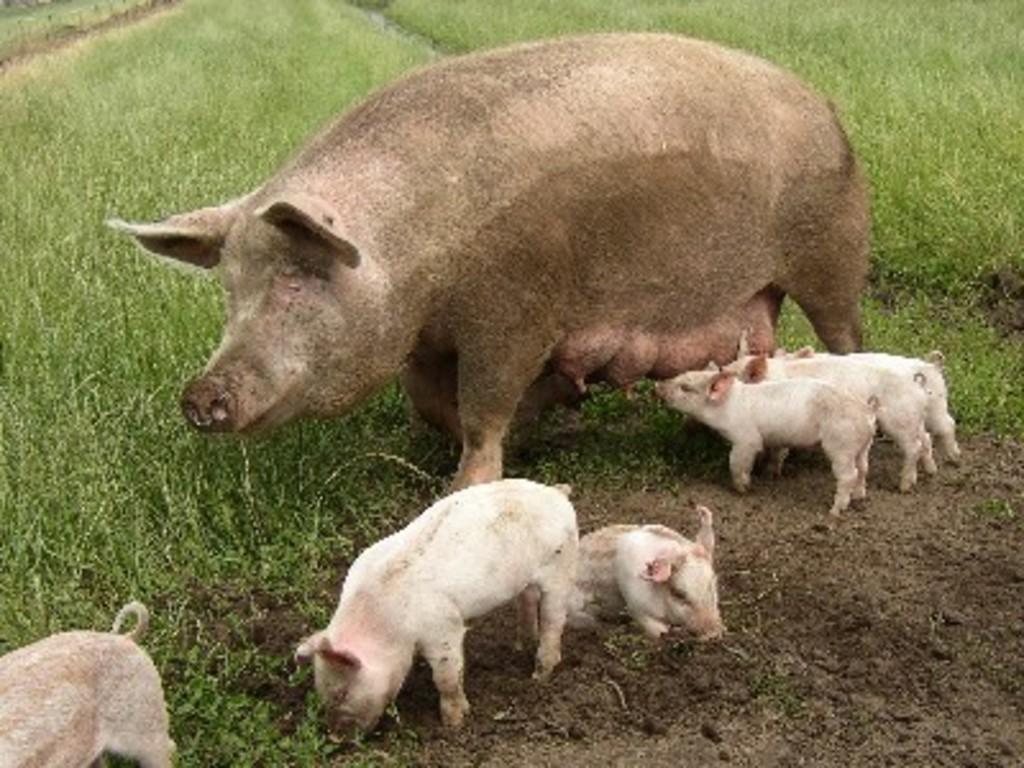Can you describe this image briefly? In this picture I can see a pig and piglets, and in the background there is grass. 